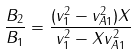<formula> <loc_0><loc_0><loc_500><loc_500>\frac { B _ { 2 \| } } { B _ { 1 \| } } = \frac { ( v _ { 1 } ^ { 2 } - v _ { A 1 } ^ { 2 } ) X } { v _ { 1 } ^ { 2 } - X v _ { A 1 } ^ { 2 } }</formula> 